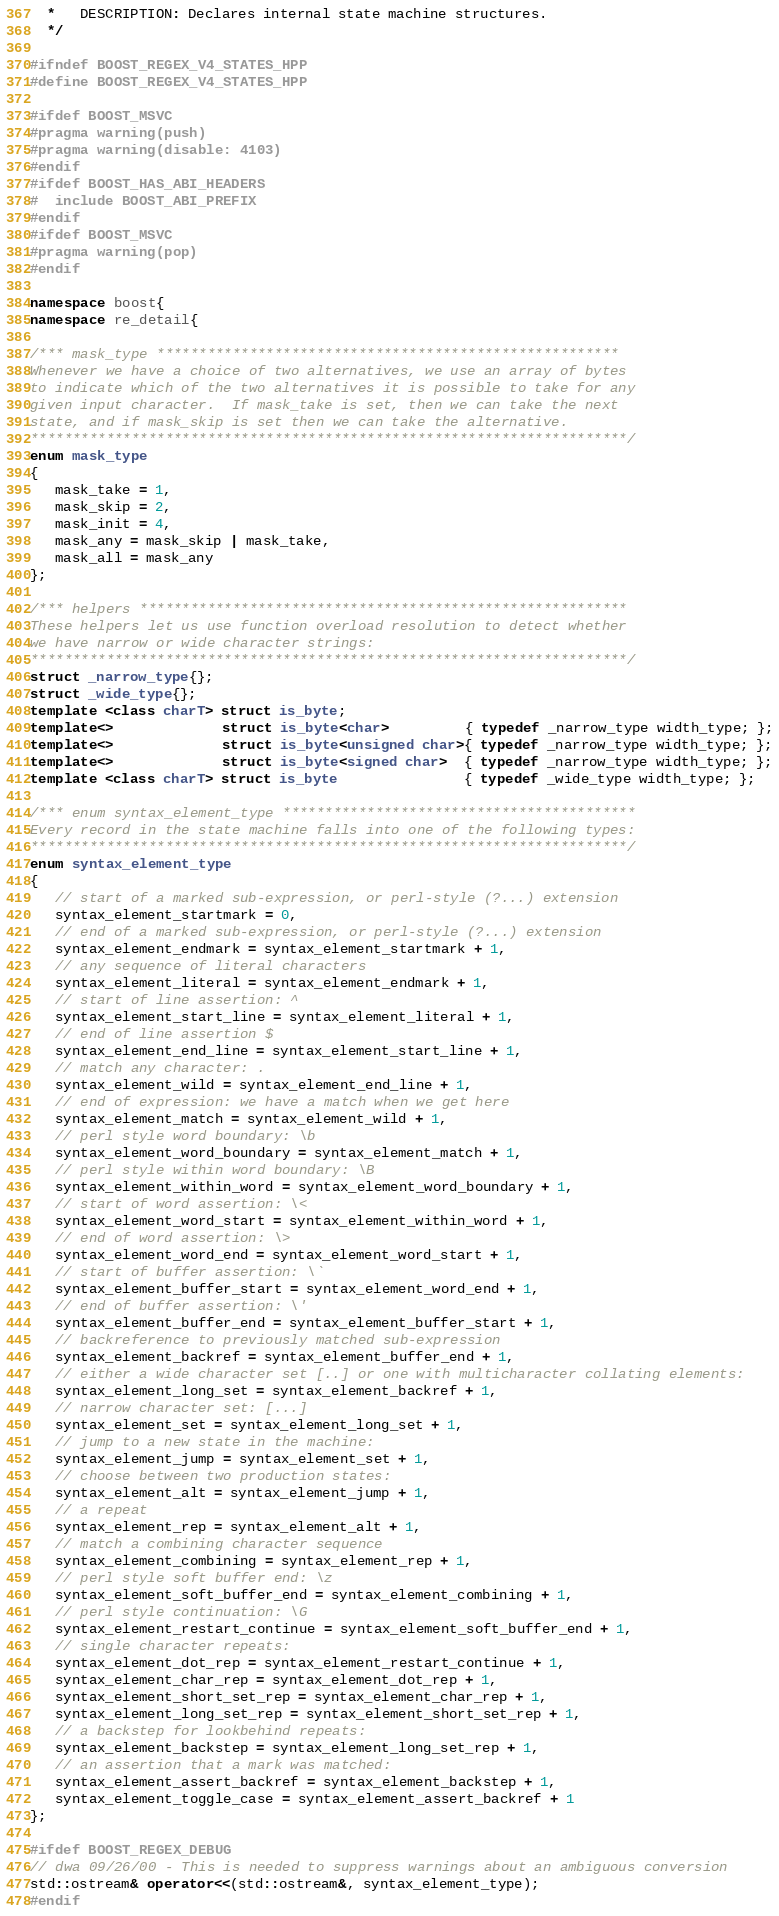Convert code to text. <code><loc_0><loc_0><loc_500><loc_500><_C++_>  *   DESCRIPTION: Declares internal state machine structures.
  */

#ifndef BOOST_REGEX_V4_STATES_HPP
#define BOOST_REGEX_V4_STATES_HPP

#ifdef BOOST_MSVC
#pragma warning(push)
#pragma warning(disable: 4103)
#endif
#ifdef BOOST_HAS_ABI_HEADERS
#  include BOOST_ABI_PREFIX
#endif
#ifdef BOOST_MSVC
#pragma warning(pop)
#endif

namespace boost{
namespace re_detail{

/*** mask_type *******************************************************
Whenever we have a choice of two alternatives, we use an array of bytes
to indicate which of the two alternatives it is possible to take for any
given input character.  If mask_take is set, then we can take the next 
state, and if mask_skip is set then we can take the alternative.
***********************************************************************/
enum mask_type
{
   mask_take = 1,
   mask_skip = 2,
   mask_init = 4,
   mask_any = mask_skip | mask_take,
   mask_all = mask_any
};

/*** helpers **********************************************************
These helpers let us use function overload resolution to detect whether
we have narrow or wide character strings:
***********************************************************************/
struct _narrow_type{};
struct _wide_type{};
template <class charT> struct is_byte;
template<>             struct is_byte<char>         { typedef _narrow_type width_type; };
template<>             struct is_byte<unsigned char>{ typedef _narrow_type width_type; };
template<>             struct is_byte<signed char>  { typedef _narrow_type width_type; };
template <class charT> struct is_byte               { typedef _wide_type width_type; };

/*** enum syntax_element_type ******************************************
Every record in the state machine falls into one of the following types:
***********************************************************************/
enum syntax_element_type
{
   // start of a marked sub-expression, or perl-style (?...) extension
   syntax_element_startmark = 0,
   // end of a marked sub-expression, or perl-style (?...) extension
   syntax_element_endmark = syntax_element_startmark + 1,
   // any sequence of literal characters
   syntax_element_literal = syntax_element_endmark + 1,
   // start of line assertion: ^
   syntax_element_start_line = syntax_element_literal + 1,
   // end of line assertion $
   syntax_element_end_line = syntax_element_start_line + 1,
   // match any character: .
   syntax_element_wild = syntax_element_end_line + 1,
   // end of expression: we have a match when we get here
   syntax_element_match = syntax_element_wild + 1,
   // perl style word boundary: \b
   syntax_element_word_boundary = syntax_element_match + 1,
   // perl style within word boundary: \B
   syntax_element_within_word = syntax_element_word_boundary + 1,
   // start of word assertion: \<
   syntax_element_word_start = syntax_element_within_word + 1,
   // end of word assertion: \>
   syntax_element_word_end = syntax_element_word_start + 1,
   // start of buffer assertion: \`
   syntax_element_buffer_start = syntax_element_word_end + 1,
   // end of buffer assertion: \'
   syntax_element_buffer_end = syntax_element_buffer_start + 1,
   // backreference to previously matched sub-expression
   syntax_element_backref = syntax_element_buffer_end + 1,
   // either a wide character set [..] or one with multicharacter collating elements:
   syntax_element_long_set = syntax_element_backref + 1,
   // narrow character set: [...]
   syntax_element_set = syntax_element_long_set + 1,
   // jump to a new state in the machine:
   syntax_element_jump = syntax_element_set + 1,
   // choose between two production states:
   syntax_element_alt = syntax_element_jump + 1,
   // a repeat
   syntax_element_rep = syntax_element_alt + 1,
   // match a combining character sequence
   syntax_element_combining = syntax_element_rep + 1,
   // perl style soft buffer end: \z
   syntax_element_soft_buffer_end = syntax_element_combining + 1,
   // perl style continuation: \G
   syntax_element_restart_continue = syntax_element_soft_buffer_end + 1,
   // single character repeats:
   syntax_element_dot_rep = syntax_element_restart_continue + 1,
   syntax_element_char_rep = syntax_element_dot_rep + 1,
   syntax_element_short_set_rep = syntax_element_char_rep + 1,
   syntax_element_long_set_rep = syntax_element_short_set_rep + 1,
   // a backstep for lookbehind repeats:
   syntax_element_backstep = syntax_element_long_set_rep + 1,
   // an assertion that a mark was matched:
   syntax_element_assert_backref = syntax_element_backstep + 1,
   syntax_element_toggle_case = syntax_element_assert_backref + 1
};

#ifdef BOOST_REGEX_DEBUG
// dwa 09/26/00 - This is needed to suppress warnings about an ambiguous conversion
std::ostream& operator<<(std::ostream&, syntax_element_type);
#endif
</code> 